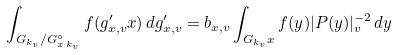<formula> <loc_0><loc_0><loc_500><loc_500>\int _ { G _ { k _ { v } } / G ^ { \circ } _ { x \, k _ { v } } } f ( g _ { x , v } ^ { \prime } x ) \, d g _ { x , v } ^ { \prime } = b _ { x , v } \int _ { G _ { k _ { v } } x } f ( y ) | P ( y ) | _ { v } ^ { - 2 } \, d y</formula> 